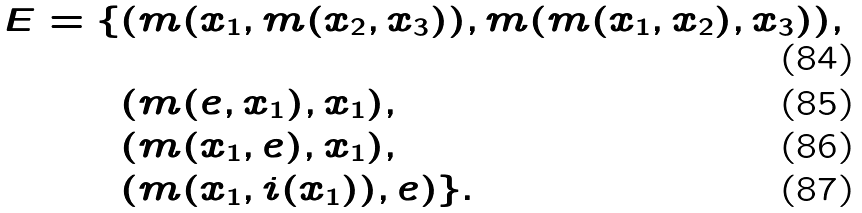Convert formula to latex. <formula><loc_0><loc_0><loc_500><loc_500>E = \{ & ( m ( x _ { 1 } , m ( x _ { 2 } , x _ { 3 } ) ) , m ( m ( x _ { 1 } , x _ { 2 } ) , x _ { 3 } ) ) , \\ & ( m ( e , x _ { 1 } ) , x _ { 1 } ) , \\ & ( m ( x _ { 1 } , e ) , x _ { 1 } ) , \\ & ( m ( x _ { 1 } , i ( x _ { 1 } ) ) , e ) \} .</formula> 